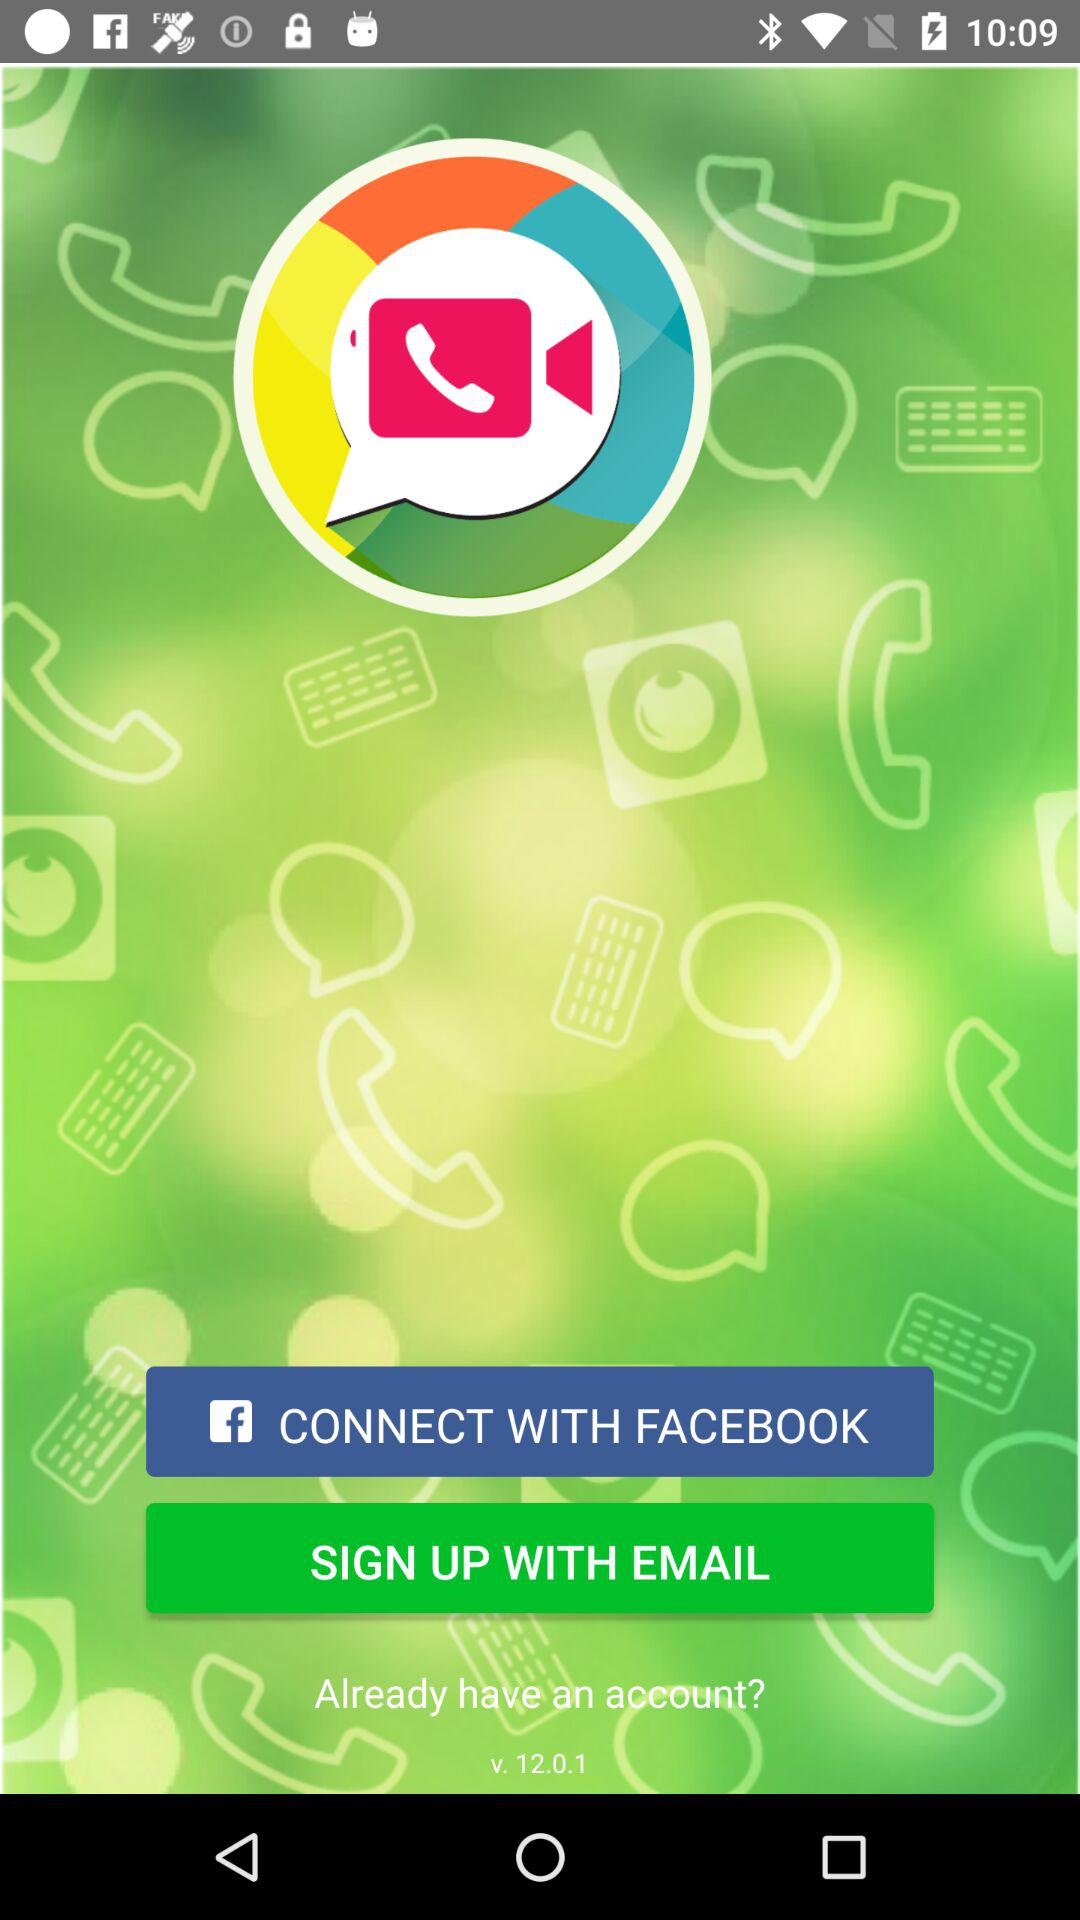What other application can be used to connect? The other application that can be used to connect is "FACEBOOK". 